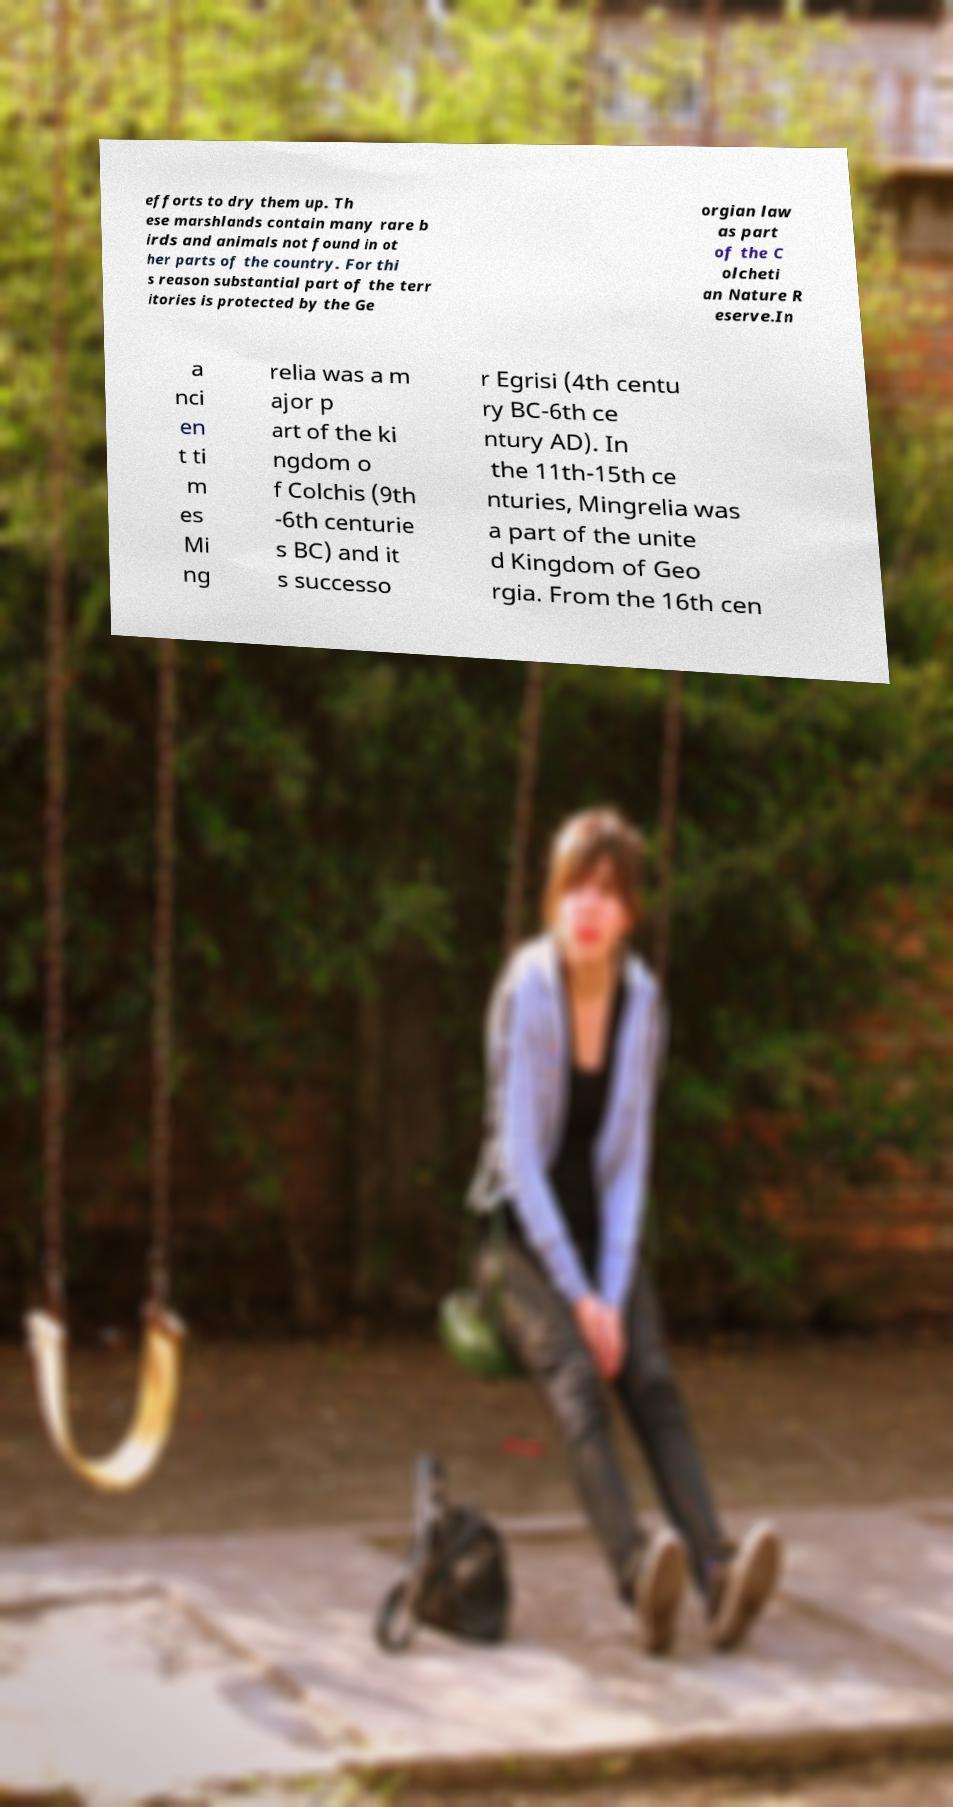Please read and relay the text visible in this image. What does it say? efforts to dry them up. Th ese marshlands contain many rare b irds and animals not found in ot her parts of the country. For thi s reason substantial part of the terr itories is protected by the Ge orgian law as part of the C olcheti an Nature R eserve.In a nci en t ti m es Mi ng relia was a m ajor p art of the ki ngdom o f Colchis (9th -6th centurie s BC) and it s successo r Egrisi (4th centu ry BC-6th ce ntury AD). In the 11th-15th ce nturies, Mingrelia was a part of the unite d Kingdom of Geo rgia. From the 16th cen 